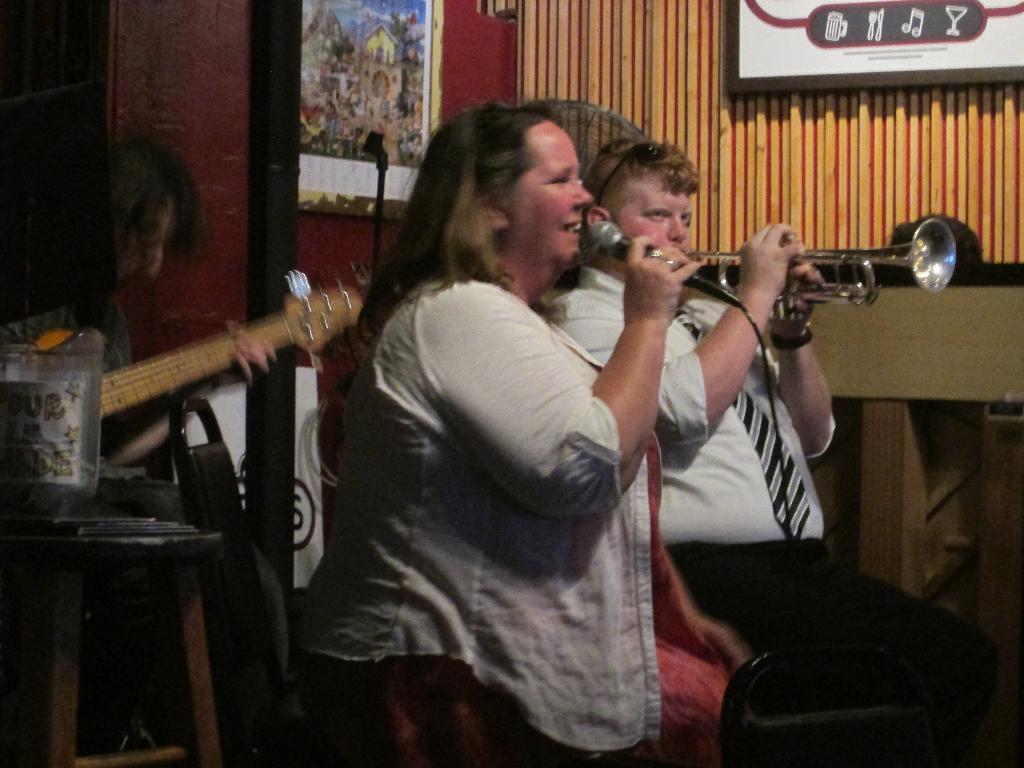In one or two sentences, can you explain what this image depicts? In the picture we can see some group of persons playing musical instruments and there is a lady person holding microphone in her hands and in the background of the picture there is a wall to which some photo frames are attached. 